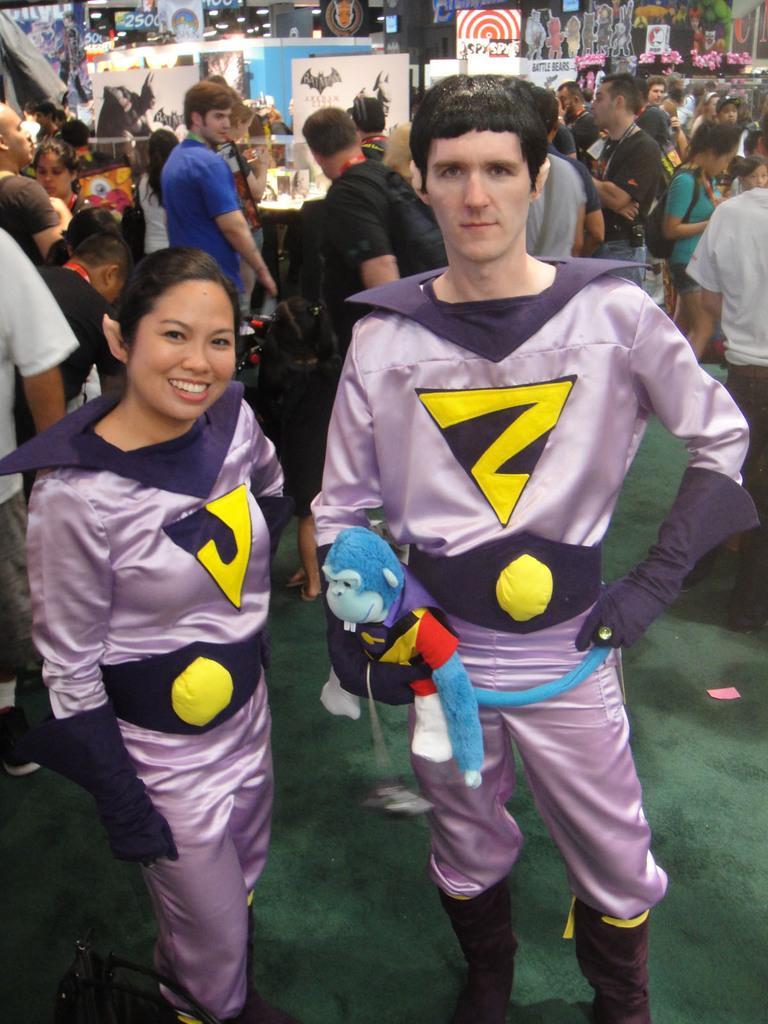Could you give a brief overview of what you see in this image? Here I can see a man and a woman are wearing same dress which is in violet color. They are standing, smiling and giving pose for the picture. I can see a toy in man's hand. In the background there are many people are standing. It is looking like an exhibition. I can see some boards on the tables. 